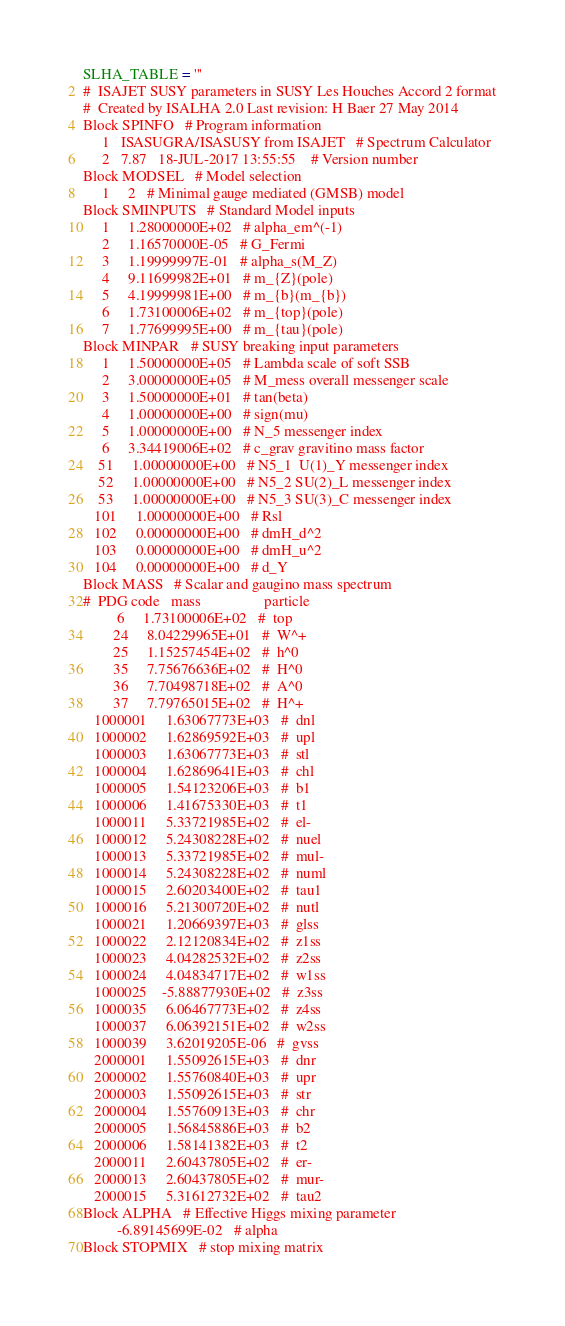Convert code to text. <code><loc_0><loc_0><loc_500><loc_500><_Python_>
SLHA_TABLE = '''
#  ISAJET SUSY parameters in SUSY Les Houches Accord 2 format
#  Created by ISALHA 2.0 Last revision: H Baer 27 May 2014
Block SPINFO   # Program information
     1   ISASUGRA/ISASUSY from ISAJET   # Spectrum Calculator
     2   7.87   18-JUL-2017 13:55:55    # Version number
Block MODSEL   # Model selection
     1     2   # Minimal gauge mediated (GMSB) model               
Block SMINPUTS   # Standard Model inputs
     1     1.28000000E+02   # alpha_em^(-1)
     2     1.16570000E-05   # G_Fermi
     3     1.19999997E-01   # alpha_s(M_Z)
     4     9.11699982E+01   # m_{Z}(pole)
     5     4.19999981E+00   # m_{b}(m_{b})
     6     1.73100006E+02   # m_{top}(pole)
     7     1.77699995E+00   # m_{tau}(pole)
Block MINPAR   # SUSY breaking input parameters
     1     1.50000000E+05   # Lambda scale of soft SSB
     2     3.00000000E+05   # M_mess overall messenger scale
     3     1.50000000E+01   # tan(beta)
     4     1.00000000E+00   # sign(mu)
     5     1.00000000E+00   # N_5 messenger index
     6     3.34419006E+02   # c_grav gravitino mass factor
    51     1.00000000E+00   # N5_1  U(1)_Y messenger index
    52     1.00000000E+00   # N5_2 SU(2)_L messenger index
    53     1.00000000E+00   # N5_3 SU(3)_C messenger index
   101     1.00000000E+00   # Rsl
   102     0.00000000E+00   # dmH_d^2
   103     0.00000000E+00   # dmH_u^2
   104     0.00000000E+00   # d_Y
Block MASS   # Scalar and gaugino mass spectrum
#  PDG code   mass                 particle
         6     1.73100006E+02   #  top            
        24     8.04229965E+01   #  W^+
        25     1.15257454E+02   #  h^0            
        35     7.75676636E+02   #  H^0            
        36     7.70498718E+02   #  A^0            
        37     7.79765015E+02   #  H^+            
   1000001     1.63067773E+03   #  dnl            
   1000002     1.62869592E+03   #  upl            
   1000003     1.63067773E+03   #  stl            
   1000004     1.62869641E+03   #  chl            
   1000005     1.54123206E+03   #  b1             
   1000006     1.41675330E+03   #  t1             
   1000011     5.33721985E+02   #  el-            
   1000012     5.24308228E+02   #  nuel           
   1000013     5.33721985E+02   #  mul-           
   1000014     5.24308228E+02   #  numl           
   1000015     2.60203400E+02   #  tau1           
   1000016     5.21300720E+02   #  nutl           
   1000021     1.20669397E+03   #  glss           
   1000022     2.12120834E+02   #  z1ss           
   1000023     4.04282532E+02   #  z2ss           
   1000024     4.04834717E+02   #  w1ss           
   1000025    -5.88877930E+02   #  z3ss           
   1000035     6.06467773E+02   #  z4ss           
   1000037     6.06392151E+02   #  w2ss           
   1000039     3.62019205E-06   #  gvss
   2000001     1.55092615E+03   #  dnr            
   2000002     1.55760840E+03   #  upr            
   2000003     1.55092615E+03   #  str            
   2000004     1.55760913E+03   #  chr            
   2000005     1.56845886E+03   #  b2             
   2000006     1.58141382E+03   #  t2             
   2000011     2.60437805E+02   #  er-            
   2000013     2.60437805E+02   #  mur-           
   2000015     5.31612732E+02   #  tau2           
Block ALPHA   # Effective Higgs mixing parameter
         -6.89145699E-02   # alpha
Block STOPMIX   # stop mixing matrix</code> 